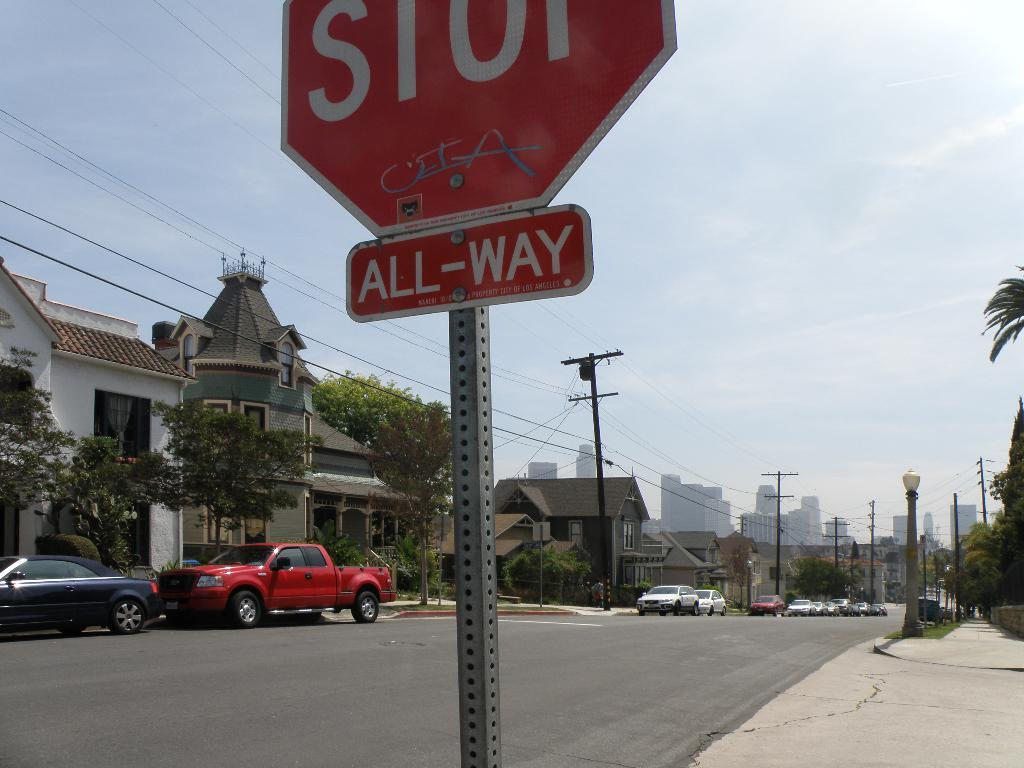Provide a one-sentence caption for the provided image. a STOP sign with an All-Way sign overlooking a residential street. 